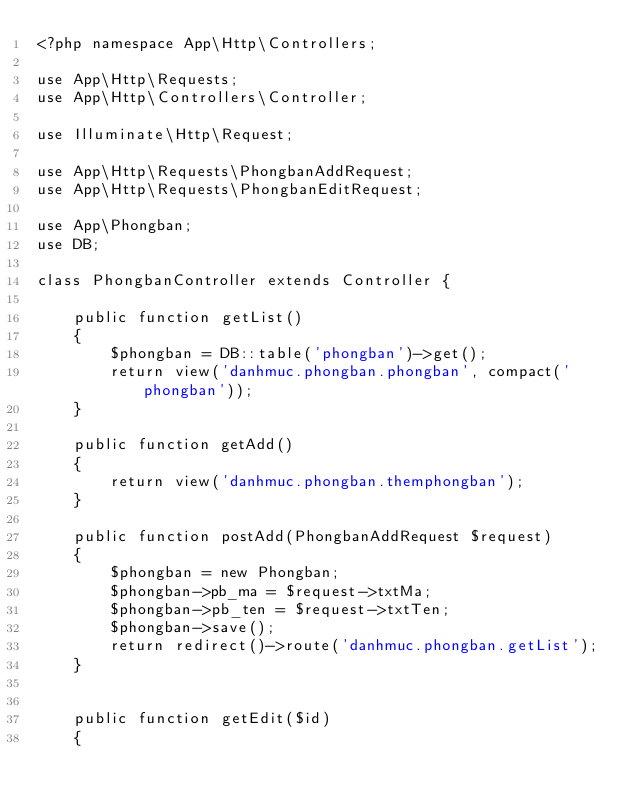<code> <loc_0><loc_0><loc_500><loc_500><_PHP_><?php namespace App\Http\Controllers;

use App\Http\Requests;
use App\Http\Controllers\Controller;

use Illuminate\Http\Request;

use App\Http\Requests\PhongbanAddRequest;
use App\Http\Requests\PhongbanEditRequest;

use App\Phongban;
use DB;

class PhongbanController extends Controller {

	public function getList()
	{
		$phongban = DB::table('phongban')->get();
		return view('danhmuc.phongban.phongban', compact('phongban'));
	}

	public function getAdd()
	{
		return view('danhmuc.phongban.themphongban');
	}

	public function postAdd(PhongbanAddRequest $request)
	{
		$phongban = new Phongban;
		$phongban->pb_ma = $request->txtMa;
		$phongban->pb_ten = $request->txtTen;
		$phongban->save();
		return redirect()->route('danhmuc.phongban.getList');
	}


	public function getEdit($id)
	{</code> 